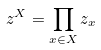Convert formula to latex. <formula><loc_0><loc_0><loc_500><loc_500>z ^ { X } = \prod _ { x \in X } z _ { x }</formula> 